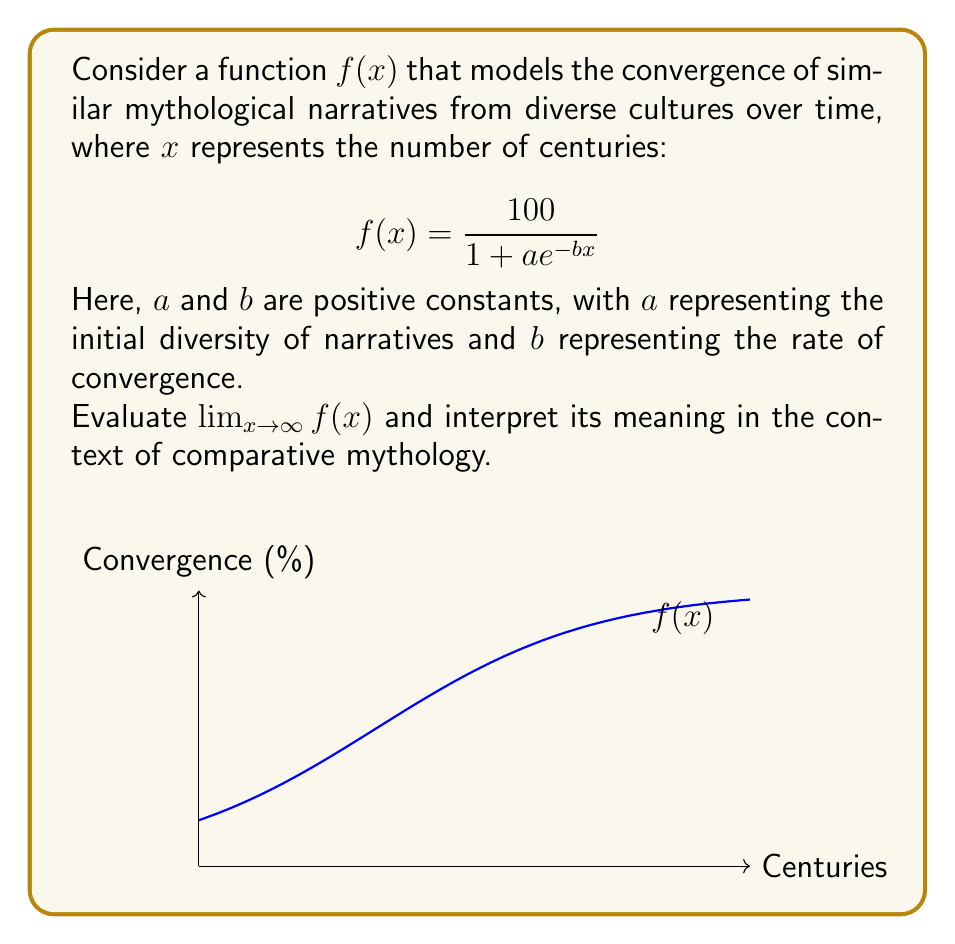Teach me how to tackle this problem. To evaluate this limit, we'll follow these steps:

1) First, let's examine the behavior of $e^{-bx}$ as $x$ approaches infinity:
   $\lim_{x \to \infty} e^{-bx} = 0$ (since $b$ is positive)

2) Now, let's look at the denominator of $f(x)$:
   $\lim_{x \to \infty} (1 + ae^{-bx}) = 1 + a \cdot 0 = 1$

3) Therefore, as $x$ approaches infinity, $f(x)$ approaches:
   $\lim_{x \to \infty} f(x) = \lim_{x \to \infty} \frac{100}{1 + ae^{-bx}} = \frac{100}{1} = 100$

Interpretation: In the context of comparative mythology, this limit suggests that as time (measured in centuries) approaches infinity, the function converges to 100. This can be interpreted as the mythological narratives from diverse cultures becoming increasingly similar over time, eventually reaching a state of complete convergence (100% similarity).

The shape of the logistic function models a gradual convergence that accelerates in the middle period before slowing down as it approaches complete similarity. This reflects the idea that cultural exchange and influence may start slowly, gain momentum, and then plateau as narratives become nearly indistinguishable.
Answer: $\lim_{x \to \infty} f(x) = 100$ 